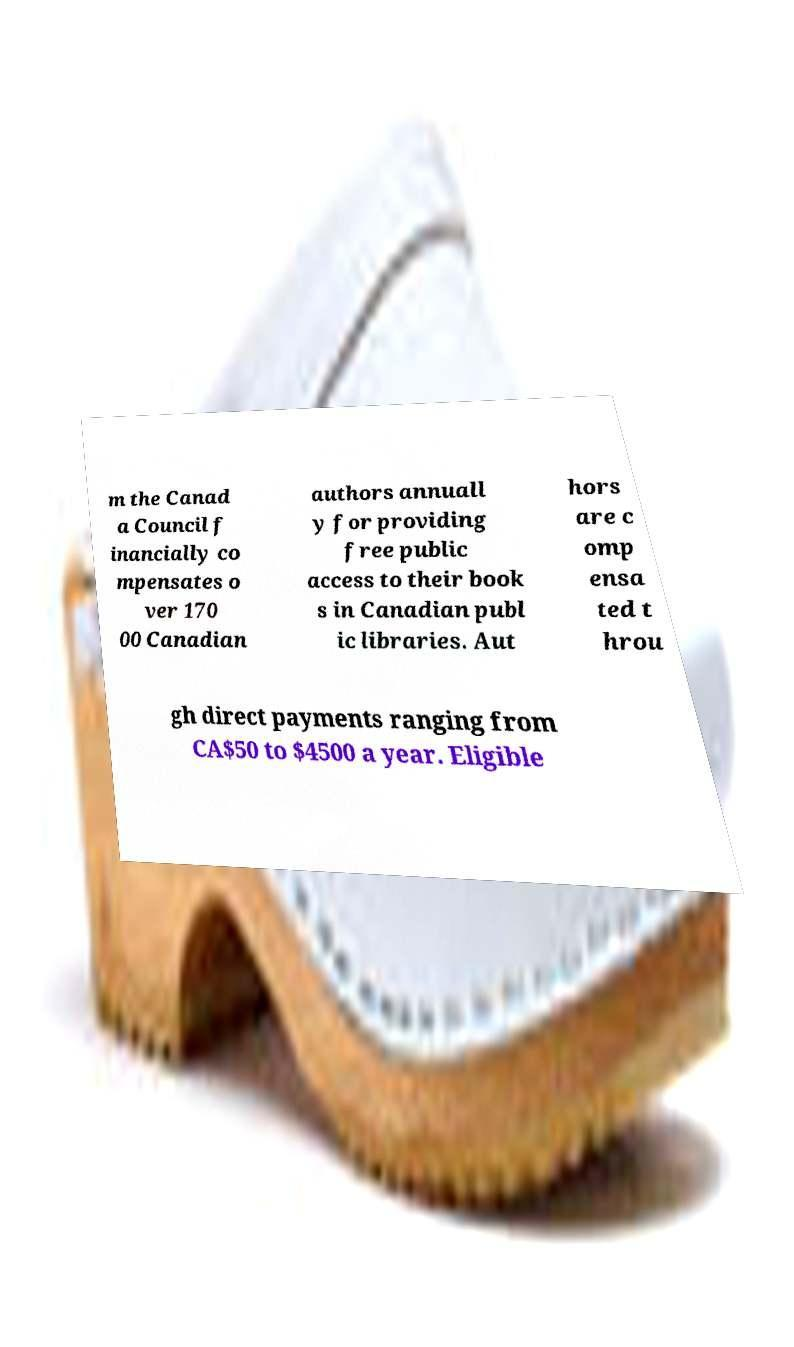Could you assist in decoding the text presented in this image and type it out clearly? m the Canad a Council f inancially co mpensates o ver 170 00 Canadian authors annuall y for providing free public access to their book s in Canadian publ ic libraries. Aut hors are c omp ensa ted t hrou gh direct payments ranging from CA$50 to $4500 a year. Eligible 